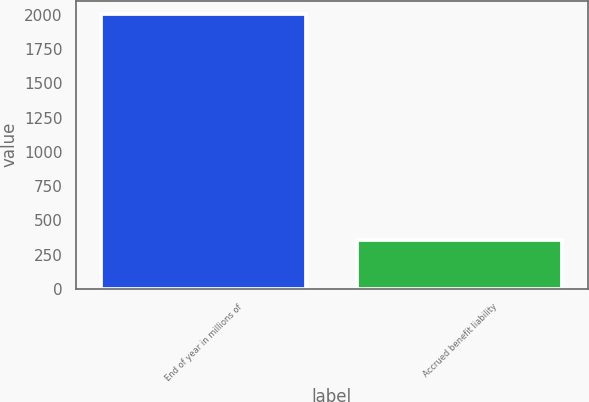Convert chart. <chart><loc_0><loc_0><loc_500><loc_500><bar_chart><fcel>End of year in millions of<fcel>Accrued benefit liability<nl><fcel>2003<fcel>361<nl></chart> 